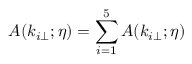Convert formula to latex. <formula><loc_0><loc_0><loc_500><loc_500>A ( k _ { i \perp } ; \eta ) = \sum _ { i = 1 } ^ { 5 } A ( k _ { i \perp } ; \eta )</formula> 